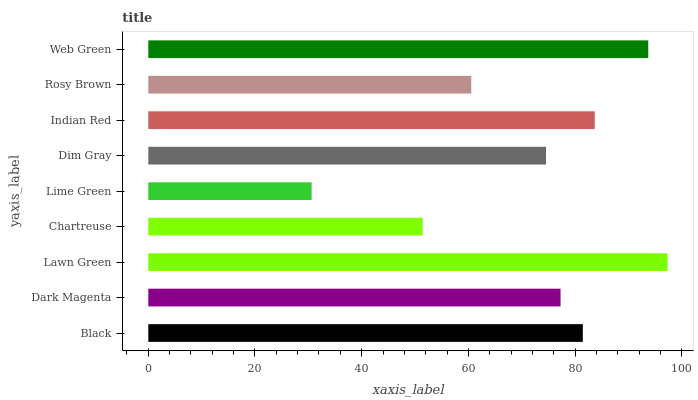Is Lime Green the minimum?
Answer yes or no. Yes. Is Lawn Green the maximum?
Answer yes or no. Yes. Is Dark Magenta the minimum?
Answer yes or no. No. Is Dark Magenta the maximum?
Answer yes or no. No. Is Black greater than Dark Magenta?
Answer yes or no. Yes. Is Dark Magenta less than Black?
Answer yes or no. Yes. Is Dark Magenta greater than Black?
Answer yes or no. No. Is Black less than Dark Magenta?
Answer yes or no. No. Is Dark Magenta the high median?
Answer yes or no. Yes. Is Dark Magenta the low median?
Answer yes or no. Yes. Is Black the high median?
Answer yes or no. No. Is Indian Red the low median?
Answer yes or no. No. 